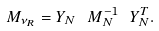<formula> <loc_0><loc_0><loc_500><loc_500>M _ { \nu _ { R } } = Y _ { N } \ M _ { N } ^ { - 1 } \ Y _ { N } ^ { T } .</formula> 